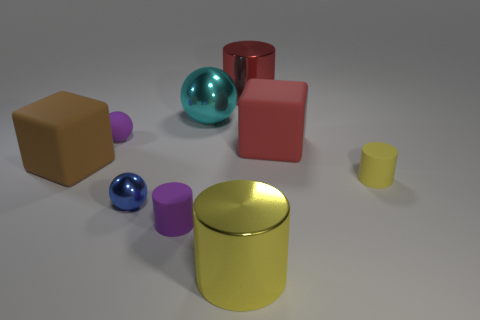Subtract all metal spheres. How many spheres are left? 1 Subtract 1 balls. How many balls are left? 2 Subtract all yellow cylinders. How many cylinders are left? 2 Add 1 small purple metal cubes. How many objects exist? 10 Subtract all cubes. How many objects are left? 7 Subtract all gray blocks. Subtract all brown cylinders. How many blocks are left? 2 Subtract all brown balls. How many yellow cylinders are left? 2 Subtract all tiny blue objects. Subtract all big cyan metal spheres. How many objects are left? 7 Add 3 tiny matte balls. How many tiny matte balls are left? 4 Add 4 big blue rubber cylinders. How many big blue rubber cylinders exist? 4 